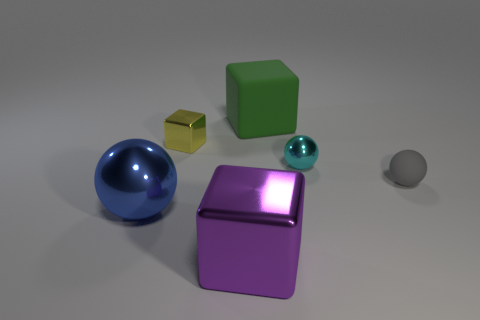Add 3 metal blocks. How many objects exist? 9 Subtract all cubes. Subtract all tiny metal balls. How many objects are left? 2 Add 6 gray objects. How many gray objects are left? 7 Add 1 small matte things. How many small matte things exist? 2 Subtract 0 purple spheres. How many objects are left? 6 